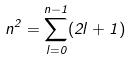<formula> <loc_0><loc_0><loc_500><loc_500>n ^ { 2 } = \sum _ { l = 0 } ^ { n - 1 } ( 2 l + 1 )</formula> 